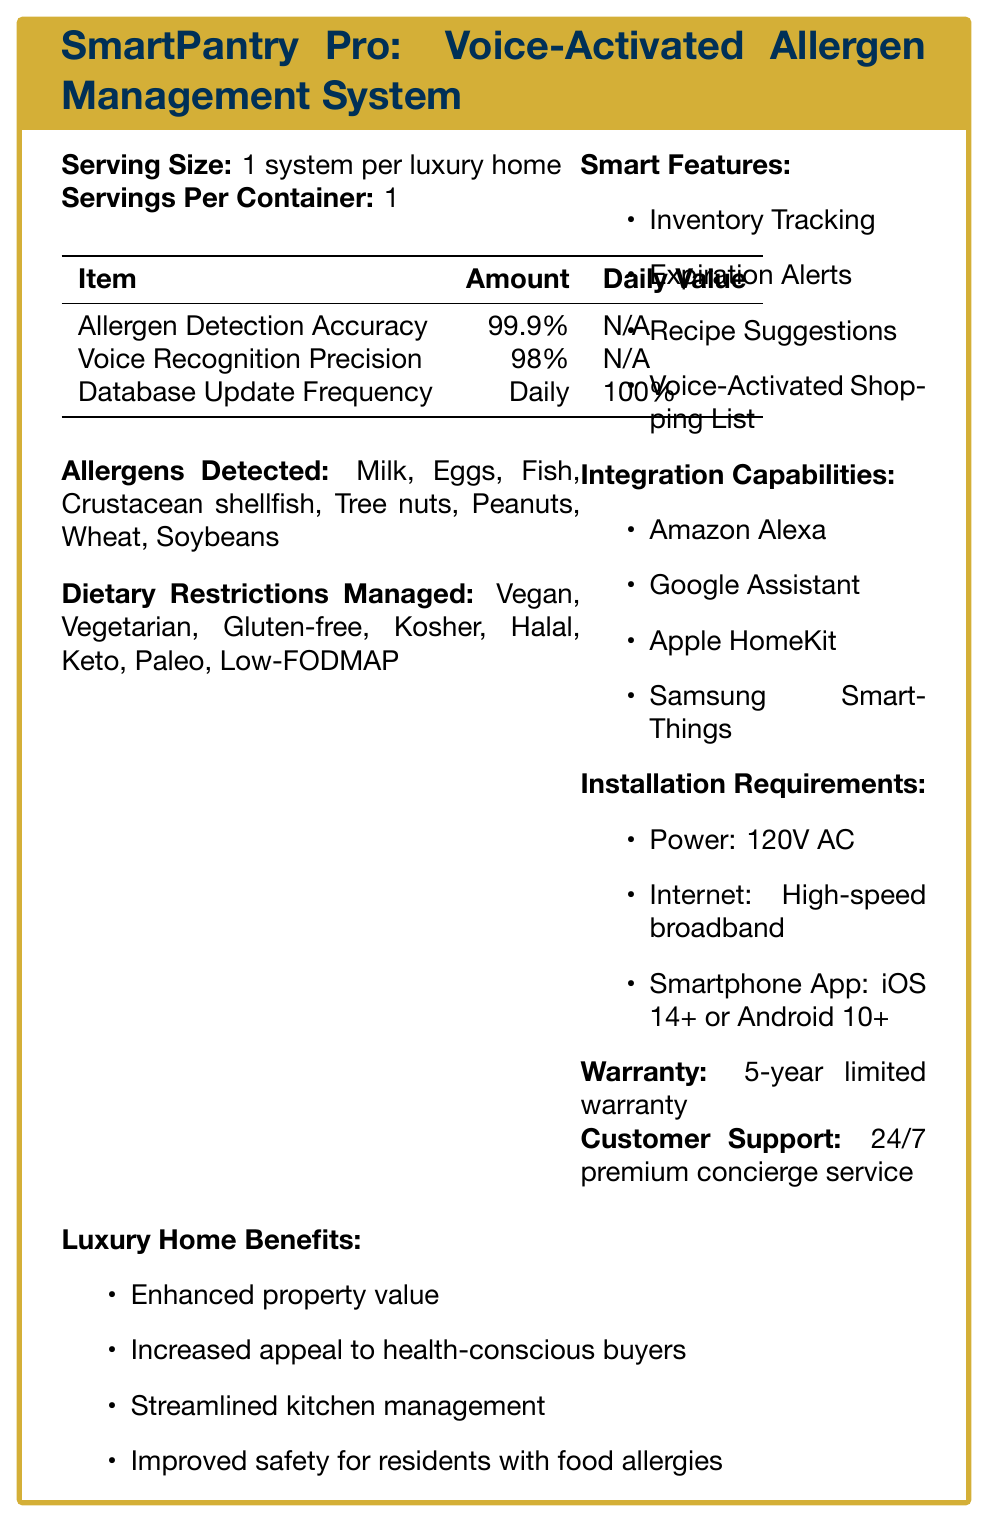what is the product name? The product name is listed at the top of the document in the title section.
Answer: SmartPantry Pro: Voice-Activated Allergen Management System what allergens can the system detect? The document lists these allergens under the "Allergens Detected" section.
Answer: Milk, Eggs, Fish, Crustacean shellfish, Tree nuts, Peanuts, Wheat, Soybeans What is the system's allergen detection accuracy? The accuracy of allergen detection is provided in the table under the "Nutrition Facts" section.
Answer: 99.9% how often is the database updated? The "Database Update Frequency" is listed as daily in the Nutrition Facts table.
Answer: Daily What dietary restrictions does the system manage? Dietary restrictions are listed under the "Dietary Restrictions Managed" section.
Answer: Vegan, Vegetarian, Gluten-free, Kosher, Halal, Keto, Paleo, Low-FODMAP which of the following is NOT a smart feature of the system? A. Inventory Tracking B. Recipe Suggestions C. Bluetooth Connectivity D. Expiration Alerts Bluetooth Connectivity is not listed under the "Smart Features" section.
Answer: C What power requirements are needed for installation? A. 120V AC B. 220V AC C. 12V DC D. 5V DC The document lists 120V AC as the power requirement under "Installation Requirements".
Answer: A Is the SmartPantry Pro compatible with Amazon Alexa? Amazon Alexa is listed under "Integration Capabilities".
Answer: Yes Describe the main benefits of integrating the system into a luxury home. The main benefits are listed under the "Luxury Home Benefits" section.
Answer: Enhanced property value, increased appeal to health-conscious buyers, streamlined kitchen management, improved safety for residents with food allergies Does the document specify the cost of the SmartPantry Pro system? The document does not provide any information about the cost.
Answer: Not enough information What kind of warranty is provided with the system? The warranty information is listed under "Warranty".
Answer: 5-year limited warranty how is the voice recognition precision described in the document? The precision for voice recognition is listed in the Nutrition Facts table.
Answer: 98% Can the SmartPantry Pro suggest recipes? Recipe Suggestions is listed as one of the smart features.
Answer: Yes what types of customer support are offered? The document mentions "24/7 premium concierge service" under "Customer Support".
Answer: 24/7 premium concierge service What is the primary function of the Inventory Tracking feature? The feature is described under the "Smart Features" section.
Answer: Real-time monitoring of pantry contents Which operating systems are supported by the smartphone app for installation? The supported operating systems are listed under "Installation Requirements".
Answer: iOS 14+ or Android 10+ 